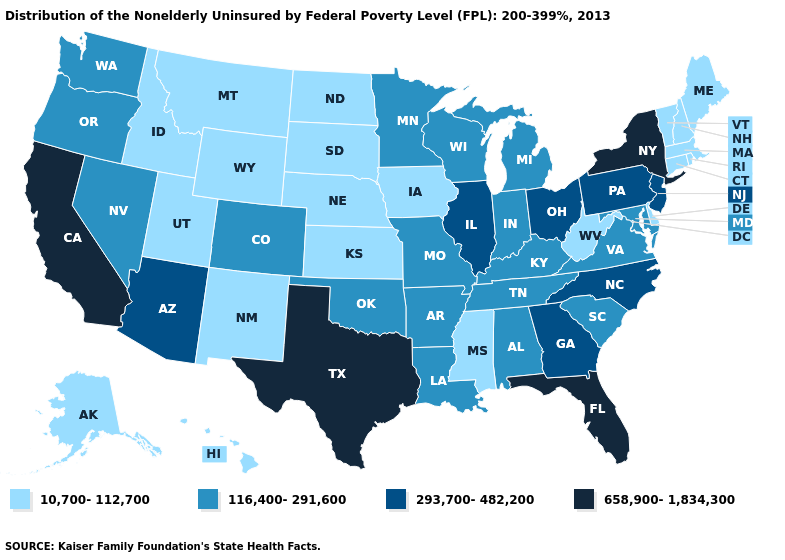What is the value of Utah?
Answer briefly. 10,700-112,700. What is the value of Illinois?
Concise answer only. 293,700-482,200. What is the value of Missouri?
Be succinct. 116,400-291,600. Name the states that have a value in the range 293,700-482,200?
Concise answer only. Arizona, Georgia, Illinois, New Jersey, North Carolina, Ohio, Pennsylvania. How many symbols are there in the legend?
Be succinct. 4. What is the value of Oklahoma?
Answer briefly. 116,400-291,600. What is the lowest value in the West?
Quick response, please. 10,700-112,700. Does West Virginia have the highest value in the South?
Keep it brief. No. Which states have the lowest value in the Northeast?
Concise answer only. Connecticut, Maine, Massachusetts, New Hampshire, Rhode Island, Vermont. What is the value of Kansas?
Be succinct. 10,700-112,700. What is the lowest value in the West?
Short answer required. 10,700-112,700. How many symbols are there in the legend?
Concise answer only. 4. Among the states that border Kentucky , does Tennessee have the highest value?
Keep it brief. No. What is the value of Wisconsin?
Keep it brief. 116,400-291,600. 